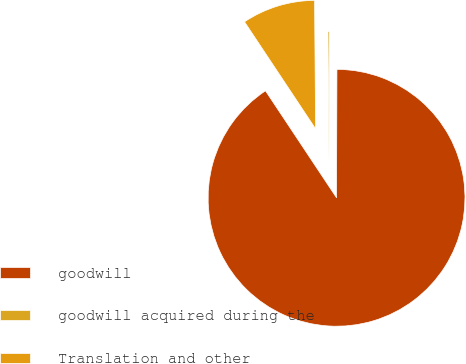<chart> <loc_0><loc_0><loc_500><loc_500><pie_chart><fcel>goodwill<fcel>goodwill acquired during the<fcel>Translation and other<nl><fcel>90.62%<fcel>0.17%<fcel>9.21%<nl></chart> 